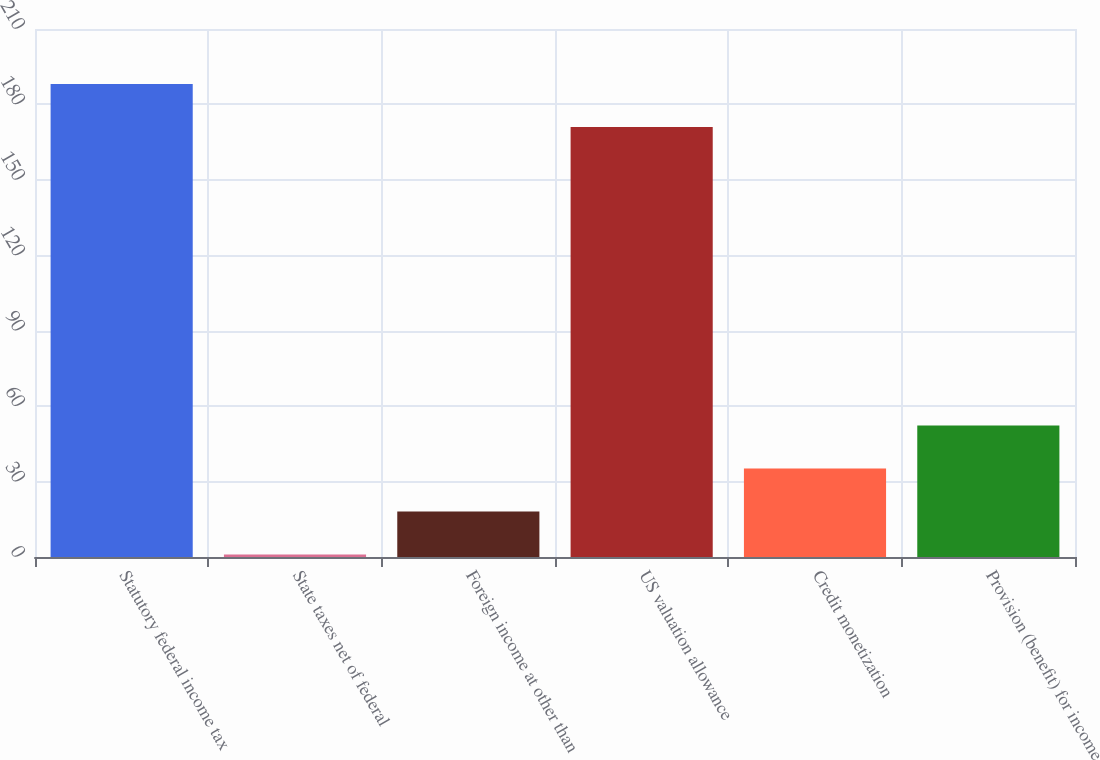Convert chart. <chart><loc_0><loc_0><loc_500><loc_500><bar_chart><fcel>Statutory federal income tax<fcel>State taxes net of federal<fcel>Foreign income at other than<fcel>US valuation allowance<fcel>Credit monetization<fcel>Provision (benefit) for income<nl><fcel>188.1<fcel>1<fcel>18.1<fcel>171<fcel>35.2<fcel>52.3<nl></chart> 